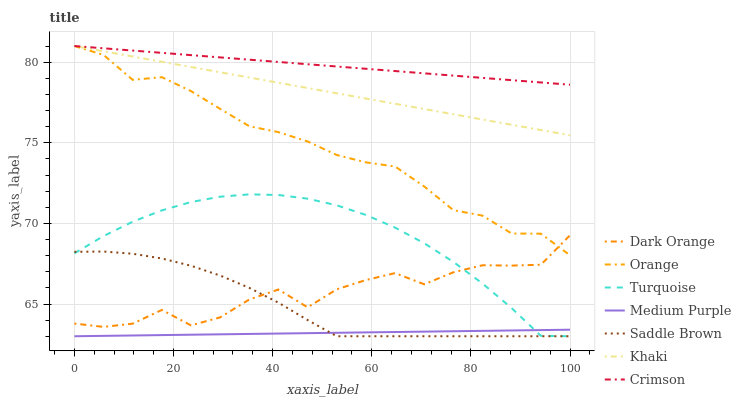Does Medium Purple have the minimum area under the curve?
Answer yes or no. Yes. Does Crimson have the maximum area under the curve?
Answer yes or no. Yes. Does Turquoise have the minimum area under the curve?
Answer yes or no. No. Does Turquoise have the maximum area under the curve?
Answer yes or no. No. Is Crimson the smoothest?
Answer yes or no. Yes. Is Dark Orange the roughest?
Answer yes or no. Yes. Is Turquoise the smoothest?
Answer yes or no. No. Is Turquoise the roughest?
Answer yes or no. No. Does Turquoise have the lowest value?
Answer yes or no. Yes. Does Khaki have the lowest value?
Answer yes or no. No. Does Orange have the highest value?
Answer yes or no. Yes. Does Turquoise have the highest value?
Answer yes or no. No. Is Saddle Brown less than Khaki?
Answer yes or no. Yes. Is Crimson greater than Saddle Brown?
Answer yes or no. Yes. Does Turquoise intersect Saddle Brown?
Answer yes or no. Yes. Is Turquoise less than Saddle Brown?
Answer yes or no. No. Is Turquoise greater than Saddle Brown?
Answer yes or no. No. Does Saddle Brown intersect Khaki?
Answer yes or no. No. 